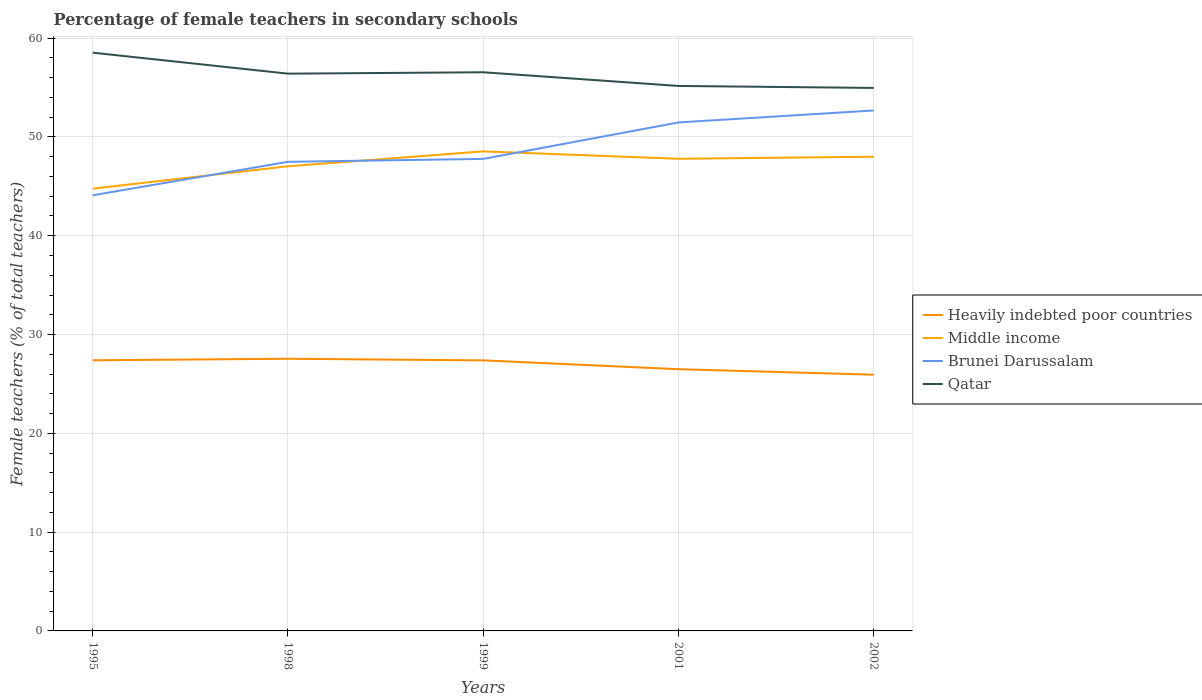How many different coloured lines are there?
Provide a short and direct response. 4. Across all years, what is the maximum percentage of female teachers in Heavily indebted poor countries?
Your answer should be compact. 25.93. In which year was the percentage of female teachers in Heavily indebted poor countries maximum?
Make the answer very short. 2002. What is the total percentage of female teachers in Brunei Darussalam in the graph?
Your answer should be very brief. -4.9. What is the difference between the highest and the second highest percentage of female teachers in Heavily indebted poor countries?
Your answer should be very brief. 1.61. Does the graph contain grids?
Give a very brief answer. Yes. Where does the legend appear in the graph?
Give a very brief answer. Center right. What is the title of the graph?
Your answer should be compact. Percentage of female teachers in secondary schools. Does "Australia" appear as one of the legend labels in the graph?
Offer a very short reply. No. What is the label or title of the Y-axis?
Your answer should be compact. Female teachers (% of total teachers). What is the Female teachers (% of total teachers) of Heavily indebted poor countries in 1995?
Ensure brevity in your answer.  27.39. What is the Female teachers (% of total teachers) in Middle income in 1995?
Provide a succinct answer. 44.76. What is the Female teachers (% of total teachers) in Brunei Darussalam in 1995?
Offer a terse response. 44.09. What is the Female teachers (% of total teachers) in Qatar in 1995?
Offer a very short reply. 58.53. What is the Female teachers (% of total teachers) of Heavily indebted poor countries in 1998?
Keep it short and to the point. 27.55. What is the Female teachers (% of total teachers) of Middle income in 1998?
Your response must be concise. 47.03. What is the Female teachers (% of total teachers) in Brunei Darussalam in 1998?
Keep it short and to the point. 47.48. What is the Female teachers (% of total teachers) of Qatar in 1998?
Provide a succinct answer. 56.4. What is the Female teachers (% of total teachers) in Heavily indebted poor countries in 1999?
Offer a terse response. 27.38. What is the Female teachers (% of total teachers) in Middle income in 1999?
Give a very brief answer. 48.54. What is the Female teachers (% of total teachers) in Brunei Darussalam in 1999?
Provide a short and direct response. 47.78. What is the Female teachers (% of total teachers) in Qatar in 1999?
Your response must be concise. 56.54. What is the Female teachers (% of total teachers) in Heavily indebted poor countries in 2001?
Offer a terse response. 26.49. What is the Female teachers (% of total teachers) of Middle income in 2001?
Make the answer very short. 47.79. What is the Female teachers (% of total teachers) of Brunei Darussalam in 2001?
Give a very brief answer. 51.47. What is the Female teachers (% of total teachers) in Qatar in 2001?
Provide a short and direct response. 55.16. What is the Female teachers (% of total teachers) of Heavily indebted poor countries in 2002?
Your response must be concise. 25.93. What is the Female teachers (% of total teachers) of Middle income in 2002?
Your answer should be very brief. 48. What is the Female teachers (% of total teachers) of Brunei Darussalam in 2002?
Give a very brief answer. 52.68. What is the Female teachers (% of total teachers) in Qatar in 2002?
Keep it short and to the point. 54.96. Across all years, what is the maximum Female teachers (% of total teachers) in Heavily indebted poor countries?
Offer a very short reply. 27.55. Across all years, what is the maximum Female teachers (% of total teachers) of Middle income?
Provide a short and direct response. 48.54. Across all years, what is the maximum Female teachers (% of total teachers) in Brunei Darussalam?
Give a very brief answer. 52.68. Across all years, what is the maximum Female teachers (% of total teachers) of Qatar?
Offer a terse response. 58.53. Across all years, what is the minimum Female teachers (% of total teachers) of Heavily indebted poor countries?
Offer a terse response. 25.93. Across all years, what is the minimum Female teachers (% of total teachers) in Middle income?
Make the answer very short. 44.76. Across all years, what is the minimum Female teachers (% of total teachers) in Brunei Darussalam?
Make the answer very short. 44.09. Across all years, what is the minimum Female teachers (% of total teachers) in Qatar?
Make the answer very short. 54.96. What is the total Female teachers (% of total teachers) in Heavily indebted poor countries in the graph?
Your answer should be very brief. 134.75. What is the total Female teachers (% of total teachers) in Middle income in the graph?
Give a very brief answer. 236.12. What is the total Female teachers (% of total teachers) in Brunei Darussalam in the graph?
Your answer should be very brief. 243.5. What is the total Female teachers (% of total teachers) of Qatar in the graph?
Your answer should be compact. 281.6. What is the difference between the Female teachers (% of total teachers) in Heavily indebted poor countries in 1995 and that in 1998?
Ensure brevity in your answer.  -0.16. What is the difference between the Female teachers (% of total teachers) in Middle income in 1995 and that in 1998?
Ensure brevity in your answer.  -2.26. What is the difference between the Female teachers (% of total teachers) in Brunei Darussalam in 1995 and that in 1998?
Offer a terse response. -3.39. What is the difference between the Female teachers (% of total teachers) in Qatar in 1995 and that in 1998?
Keep it short and to the point. 2.12. What is the difference between the Female teachers (% of total teachers) of Heavily indebted poor countries in 1995 and that in 1999?
Your answer should be compact. 0.01. What is the difference between the Female teachers (% of total teachers) of Middle income in 1995 and that in 1999?
Provide a short and direct response. -3.77. What is the difference between the Female teachers (% of total teachers) of Brunei Darussalam in 1995 and that in 1999?
Your response must be concise. -3.68. What is the difference between the Female teachers (% of total teachers) of Qatar in 1995 and that in 1999?
Your answer should be very brief. 1.98. What is the difference between the Female teachers (% of total teachers) in Heavily indebted poor countries in 1995 and that in 2001?
Your response must be concise. 0.9. What is the difference between the Female teachers (% of total teachers) in Middle income in 1995 and that in 2001?
Offer a terse response. -3.02. What is the difference between the Female teachers (% of total teachers) in Brunei Darussalam in 1995 and that in 2001?
Offer a very short reply. -7.37. What is the difference between the Female teachers (% of total teachers) in Qatar in 1995 and that in 2001?
Provide a succinct answer. 3.37. What is the difference between the Female teachers (% of total teachers) in Heavily indebted poor countries in 1995 and that in 2002?
Keep it short and to the point. 1.46. What is the difference between the Female teachers (% of total teachers) in Middle income in 1995 and that in 2002?
Your answer should be compact. -3.23. What is the difference between the Female teachers (% of total teachers) of Brunei Darussalam in 1995 and that in 2002?
Give a very brief answer. -8.59. What is the difference between the Female teachers (% of total teachers) of Qatar in 1995 and that in 2002?
Provide a short and direct response. 3.57. What is the difference between the Female teachers (% of total teachers) in Heavily indebted poor countries in 1998 and that in 1999?
Provide a succinct answer. 0.17. What is the difference between the Female teachers (% of total teachers) of Middle income in 1998 and that in 1999?
Ensure brevity in your answer.  -1.51. What is the difference between the Female teachers (% of total teachers) in Brunei Darussalam in 1998 and that in 1999?
Give a very brief answer. -0.29. What is the difference between the Female teachers (% of total teachers) in Qatar in 1998 and that in 1999?
Your response must be concise. -0.14. What is the difference between the Female teachers (% of total teachers) of Heavily indebted poor countries in 1998 and that in 2001?
Keep it short and to the point. 1.06. What is the difference between the Female teachers (% of total teachers) of Middle income in 1998 and that in 2001?
Keep it short and to the point. -0.76. What is the difference between the Female teachers (% of total teachers) in Brunei Darussalam in 1998 and that in 2001?
Provide a succinct answer. -3.98. What is the difference between the Female teachers (% of total teachers) in Qatar in 1998 and that in 2001?
Provide a succinct answer. 1.25. What is the difference between the Female teachers (% of total teachers) of Heavily indebted poor countries in 1998 and that in 2002?
Offer a very short reply. 1.61. What is the difference between the Female teachers (% of total teachers) of Middle income in 1998 and that in 2002?
Your response must be concise. -0.97. What is the difference between the Female teachers (% of total teachers) of Brunei Darussalam in 1998 and that in 2002?
Your answer should be very brief. -5.2. What is the difference between the Female teachers (% of total teachers) of Qatar in 1998 and that in 2002?
Your answer should be very brief. 1.44. What is the difference between the Female teachers (% of total teachers) of Heavily indebted poor countries in 1999 and that in 2001?
Ensure brevity in your answer.  0.89. What is the difference between the Female teachers (% of total teachers) in Middle income in 1999 and that in 2001?
Provide a succinct answer. 0.75. What is the difference between the Female teachers (% of total teachers) of Brunei Darussalam in 1999 and that in 2001?
Your answer should be compact. -3.69. What is the difference between the Female teachers (% of total teachers) in Qatar in 1999 and that in 2001?
Give a very brief answer. 1.39. What is the difference between the Female teachers (% of total teachers) of Heavily indebted poor countries in 1999 and that in 2002?
Provide a succinct answer. 1.45. What is the difference between the Female teachers (% of total teachers) in Middle income in 1999 and that in 2002?
Provide a succinct answer. 0.54. What is the difference between the Female teachers (% of total teachers) in Brunei Darussalam in 1999 and that in 2002?
Your answer should be very brief. -4.9. What is the difference between the Female teachers (% of total teachers) in Qatar in 1999 and that in 2002?
Give a very brief answer. 1.58. What is the difference between the Female teachers (% of total teachers) of Heavily indebted poor countries in 2001 and that in 2002?
Ensure brevity in your answer.  0.56. What is the difference between the Female teachers (% of total teachers) of Middle income in 2001 and that in 2002?
Your answer should be very brief. -0.21. What is the difference between the Female teachers (% of total teachers) in Brunei Darussalam in 2001 and that in 2002?
Your answer should be very brief. -1.21. What is the difference between the Female teachers (% of total teachers) of Qatar in 2001 and that in 2002?
Your answer should be compact. 0.2. What is the difference between the Female teachers (% of total teachers) of Heavily indebted poor countries in 1995 and the Female teachers (% of total teachers) of Middle income in 1998?
Keep it short and to the point. -19.64. What is the difference between the Female teachers (% of total teachers) of Heavily indebted poor countries in 1995 and the Female teachers (% of total teachers) of Brunei Darussalam in 1998?
Keep it short and to the point. -20.09. What is the difference between the Female teachers (% of total teachers) of Heavily indebted poor countries in 1995 and the Female teachers (% of total teachers) of Qatar in 1998?
Provide a succinct answer. -29.01. What is the difference between the Female teachers (% of total teachers) of Middle income in 1995 and the Female teachers (% of total teachers) of Brunei Darussalam in 1998?
Provide a short and direct response. -2.72. What is the difference between the Female teachers (% of total teachers) of Middle income in 1995 and the Female teachers (% of total teachers) of Qatar in 1998?
Offer a terse response. -11.64. What is the difference between the Female teachers (% of total teachers) of Brunei Darussalam in 1995 and the Female teachers (% of total teachers) of Qatar in 1998?
Offer a terse response. -12.31. What is the difference between the Female teachers (% of total teachers) of Heavily indebted poor countries in 1995 and the Female teachers (% of total teachers) of Middle income in 1999?
Provide a short and direct response. -21.14. What is the difference between the Female teachers (% of total teachers) of Heavily indebted poor countries in 1995 and the Female teachers (% of total teachers) of Brunei Darussalam in 1999?
Provide a succinct answer. -20.38. What is the difference between the Female teachers (% of total teachers) in Heavily indebted poor countries in 1995 and the Female teachers (% of total teachers) in Qatar in 1999?
Keep it short and to the point. -29.15. What is the difference between the Female teachers (% of total teachers) in Middle income in 1995 and the Female teachers (% of total teachers) in Brunei Darussalam in 1999?
Provide a short and direct response. -3.01. What is the difference between the Female teachers (% of total teachers) in Middle income in 1995 and the Female teachers (% of total teachers) in Qatar in 1999?
Offer a terse response. -11.78. What is the difference between the Female teachers (% of total teachers) in Brunei Darussalam in 1995 and the Female teachers (% of total teachers) in Qatar in 1999?
Keep it short and to the point. -12.45. What is the difference between the Female teachers (% of total teachers) in Heavily indebted poor countries in 1995 and the Female teachers (% of total teachers) in Middle income in 2001?
Your answer should be compact. -20.4. What is the difference between the Female teachers (% of total teachers) of Heavily indebted poor countries in 1995 and the Female teachers (% of total teachers) of Brunei Darussalam in 2001?
Your response must be concise. -24.07. What is the difference between the Female teachers (% of total teachers) of Heavily indebted poor countries in 1995 and the Female teachers (% of total teachers) of Qatar in 2001?
Keep it short and to the point. -27.77. What is the difference between the Female teachers (% of total teachers) of Middle income in 1995 and the Female teachers (% of total teachers) of Brunei Darussalam in 2001?
Ensure brevity in your answer.  -6.7. What is the difference between the Female teachers (% of total teachers) of Middle income in 1995 and the Female teachers (% of total teachers) of Qatar in 2001?
Ensure brevity in your answer.  -10.39. What is the difference between the Female teachers (% of total teachers) in Brunei Darussalam in 1995 and the Female teachers (% of total teachers) in Qatar in 2001?
Make the answer very short. -11.07. What is the difference between the Female teachers (% of total teachers) of Heavily indebted poor countries in 1995 and the Female teachers (% of total teachers) of Middle income in 2002?
Your answer should be very brief. -20.6. What is the difference between the Female teachers (% of total teachers) of Heavily indebted poor countries in 1995 and the Female teachers (% of total teachers) of Brunei Darussalam in 2002?
Your response must be concise. -25.29. What is the difference between the Female teachers (% of total teachers) of Heavily indebted poor countries in 1995 and the Female teachers (% of total teachers) of Qatar in 2002?
Give a very brief answer. -27.57. What is the difference between the Female teachers (% of total teachers) in Middle income in 1995 and the Female teachers (% of total teachers) in Brunei Darussalam in 2002?
Offer a very short reply. -7.91. What is the difference between the Female teachers (% of total teachers) in Middle income in 1995 and the Female teachers (% of total teachers) in Qatar in 2002?
Keep it short and to the point. -10.2. What is the difference between the Female teachers (% of total teachers) in Brunei Darussalam in 1995 and the Female teachers (% of total teachers) in Qatar in 2002?
Offer a very short reply. -10.87. What is the difference between the Female teachers (% of total teachers) in Heavily indebted poor countries in 1998 and the Female teachers (% of total teachers) in Middle income in 1999?
Your answer should be compact. -20.99. What is the difference between the Female teachers (% of total teachers) of Heavily indebted poor countries in 1998 and the Female teachers (% of total teachers) of Brunei Darussalam in 1999?
Your answer should be very brief. -20.23. What is the difference between the Female teachers (% of total teachers) in Heavily indebted poor countries in 1998 and the Female teachers (% of total teachers) in Qatar in 1999?
Make the answer very short. -29. What is the difference between the Female teachers (% of total teachers) of Middle income in 1998 and the Female teachers (% of total teachers) of Brunei Darussalam in 1999?
Your answer should be very brief. -0.75. What is the difference between the Female teachers (% of total teachers) in Middle income in 1998 and the Female teachers (% of total teachers) in Qatar in 1999?
Make the answer very short. -9.51. What is the difference between the Female teachers (% of total teachers) in Brunei Darussalam in 1998 and the Female teachers (% of total teachers) in Qatar in 1999?
Your answer should be compact. -9.06. What is the difference between the Female teachers (% of total teachers) of Heavily indebted poor countries in 1998 and the Female teachers (% of total teachers) of Middle income in 2001?
Provide a succinct answer. -20.24. What is the difference between the Female teachers (% of total teachers) of Heavily indebted poor countries in 1998 and the Female teachers (% of total teachers) of Brunei Darussalam in 2001?
Offer a terse response. -23.92. What is the difference between the Female teachers (% of total teachers) of Heavily indebted poor countries in 1998 and the Female teachers (% of total teachers) of Qatar in 2001?
Your response must be concise. -27.61. What is the difference between the Female teachers (% of total teachers) in Middle income in 1998 and the Female teachers (% of total teachers) in Brunei Darussalam in 2001?
Your response must be concise. -4.44. What is the difference between the Female teachers (% of total teachers) in Middle income in 1998 and the Female teachers (% of total teachers) in Qatar in 2001?
Make the answer very short. -8.13. What is the difference between the Female teachers (% of total teachers) of Brunei Darussalam in 1998 and the Female teachers (% of total teachers) of Qatar in 2001?
Give a very brief answer. -7.68. What is the difference between the Female teachers (% of total teachers) in Heavily indebted poor countries in 1998 and the Female teachers (% of total teachers) in Middle income in 2002?
Offer a very short reply. -20.45. What is the difference between the Female teachers (% of total teachers) in Heavily indebted poor countries in 1998 and the Female teachers (% of total teachers) in Brunei Darussalam in 2002?
Your answer should be very brief. -25.13. What is the difference between the Female teachers (% of total teachers) of Heavily indebted poor countries in 1998 and the Female teachers (% of total teachers) of Qatar in 2002?
Your answer should be very brief. -27.41. What is the difference between the Female teachers (% of total teachers) of Middle income in 1998 and the Female teachers (% of total teachers) of Brunei Darussalam in 2002?
Ensure brevity in your answer.  -5.65. What is the difference between the Female teachers (% of total teachers) of Middle income in 1998 and the Female teachers (% of total teachers) of Qatar in 2002?
Provide a succinct answer. -7.93. What is the difference between the Female teachers (% of total teachers) in Brunei Darussalam in 1998 and the Female teachers (% of total teachers) in Qatar in 2002?
Provide a succinct answer. -7.48. What is the difference between the Female teachers (% of total teachers) in Heavily indebted poor countries in 1999 and the Female teachers (% of total teachers) in Middle income in 2001?
Your answer should be very brief. -20.41. What is the difference between the Female teachers (% of total teachers) of Heavily indebted poor countries in 1999 and the Female teachers (% of total teachers) of Brunei Darussalam in 2001?
Your response must be concise. -24.08. What is the difference between the Female teachers (% of total teachers) in Heavily indebted poor countries in 1999 and the Female teachers (% of total teachers) in Qatar in 2001?
Your response must be concise. -27.78. What is the difference between the Female teachers (% of total teachers) in Middle income in 1999 and the Female teachers (% of total teachers) in Brunei Darussalam in 2001?
Ensure brevity in your answer.  -2.93. What is the difference between the Female teachers (% of total teachers) of Middle income in 1999 and the Female teachers (% of total teachers) of Qatar in 2001?
Offer a very short reply. -6.62. What is the difference between the Female teachers (% of total teachers) in Brunei Darussalam in 1999 and the Female teachers (% of total teachers) in Qatar in 2001?
Offer a very short reply. -7.38. What is the difference between the Female teachers (% of total teachers) in Heavily indebted poor countries in 1999 and the Female teachers (% of total teachers) in Middle income in 2002?
Your answer should be compact. -20.61. What is the difference between the Female teachers (% of total teachers) of Heavily indebted poor countries in 1999 and the Female teachers (% of total teachers) of Brunei Darussalam in 2002?
Offer a terse response. -25.3. What is the difference between the Female teachers (% of total teachers) in Heavily indebted poor countries in 1999 and the Female teachers (% of total teachers) in Qatar in 2002?
Keep it short and to the point. -27.58. What is the difference between the Female teachers (% of total teachers) in Middle income in 1999 and the Female teachers (% of total teachers) in Brunei Darussalam in 2002?
Keep it short and to the point. -4.14. What is the difference between the Female teachers (% of total teachers) in Middle income in 1999 and the Female teachers (% of total teachers) in Qatar in 2002?
Offer a terse response. -6.42. What is the difference between the Female teachers (% of total teachers) in Brunei Darussalam in 1999 and the Female teachers (% of total teachers) in Qatar in 2002?
Your response must be concise. -7.18. What is the difference between the Female teachers (% of total teachers) of Heavily indebted poor countries in 2001 and the Female teachers (% of total teachers) of Middle income in 2002?
Offer a very short reply. -21.51. What is the difference between the Female teachers (% of total teachers) in Heavily indebted poor countries in 2001 and the Female teachers (% of total teachers) in Brunei Darussalam in 2002?
Make the answer very short. -26.19. What is the difference between the Female teachers (% of total teachers) in Heavily indebted poor countries in 2001 and the Female teachers (% of total teachers) in Qatar in 2002?
Your answer should be very brief. -28.47. What is the difference between the Female teachers (% of total teachers) of Middle income in 2001 and the Female teachers (% of total teachers) of Brunei Darussalam in 2002?
Provide a short and direct response. -4.89. What is the difference between the Female teachers (% of total teachers) in Middle income in 2001 and the Female teachers (% of total teachers) in Qatar in 2002?
Provide a short and direct response. -7.17. What is the difference between the Female teachers (% of total teachers) of Brunei Darussalam in 2001 and the Female teachers (% of total teachers) of Qatar in 2002?
Keep it short and to the point. -3.49. What is the average Female teachers (% of total teachers) of Heavily indebted poor countries per year?
Offer a terse response. 26.95. What is the average Female teachers (% of total teachers) of Middle income per year?
Make the answer very short. 47.22. What is the average Female teachers (% of total teachers) in Brunei Darussalam per year?
Offer a terse response. 48.7. What is the average Female teachers (% of total teachers) in Qatar per year?
Ensure brevity in your answer.  56.32. In the year 1995, what is the difference between the Female teachers (% of total teachers) of Heavily indebted poor countries and Female teachers (% of total teachers) of Middle income?
Your answer should be very brief. -17.37. In the year 1995, what is the difference between the Female teachers (% of total teachers) of Heavily indebted poor countries and Female teachers (% of total teachers) of Brunei Darussalam?
Provide a succinct answer. -16.7. In the year 1995, what is the difference between the Female teachers (% of total teachers) in Heavily indebted poor countries and Female teachers (% of total teachers) in Qatar?
Offer a terse response. -31.13. In the year 1995, what is the difference between the Female teachers (% of total teachers) in Middle income and Female teachers (% of total teachers) in Brunei Darussalam?
Your response must be concise. 0.67. In the year 1995, what is the difference between the Female teachers (% of total teachers) of Middle income and Female teachers (% of total teachers) of Qatar?
Provide a short and direct response. -13.76. In the year 1995, what is the difference between the Female teachers (% of total teachers) in Brunei Darussalam and Female teachers (% of total teachers) in Qatar?
Offer a very short reply. -14.43. In the year 1998, what is the difference between the Female teachers (% of total teachers) of Heavily indebted poor countries and Female teachers (% of total teachers) of Middle income?
Offer a terse response. -19.48. In the year 1998, what is the difference between the Female teachers (% of total teachers) in Heavily indebted poor countries and Female teachers (% of total teachers) in Brunei Darussalam?
Your answer should be compact. -19.93. In the year 1998, what is the difference between the Female teachers (% of total teachers) of Heavily indebted poor countries and Female teachers (% of total teachers) of Qatar?
Your answer should be compact. -28.86. In the year 1998, what is the difference between the Female teachers (% of total teachers) in Middle income and Female teachers (% of total teachers) in Brunei Darussalam?
Ensure brevity in your answer.  -0.45. In the year 1998, what is the difference between the Female teachers (% of total teachers) in Middle income and Female teachers (% of total teachers) in Qatar?
Provide a succinct answer. -9.38. In the year 1998, what is the difference between the Female teachers (% of total teachers) of Brunei Darussalam and Female teachers (% of total teachers) of Qatar?
Provide a short and direct response. -8.92. In the year 1999, what is the difference between the Female teachers (% of total teachers) of Heavily indebted poor countries and Female teachers (% of total teachers) of Middle income?
Your answer should be very brief. -21.15. In the year 1999, what is the difference between the Female teachers (% of total teachers) of Heavily indebted poor countries and Female teachers (% of total teachers) of Brunei Darussalam?
Your answer should be very brief. -20.39. In the year 1999, what is the difference between the Female teachers (% of total teachers) in Heavily indebted poor countries and Female teachers (% of total teachers) in Qatar?
Keep it short and to the point. -29.16. In the year 1999, what is the difference between the Female teachers (% of total teachers) in Middle income and Female teachers (% of total teachers) in Brunei Darussalam?
Your response must be concise. 0.76. In the year 1999, what is the difference between the Female teachers (% of total teachers) of Middle income and Female teachers (% of total teachers) of Qatar?
Offer a terse response. -8.01. In the year 1999, what is the difference between the Female teachers (% of total teachers) in Brunei Darussalam and Female teachers (% of total teachers) in Qatar?
Offer a terse response. -8.77. In the year 2001, what is the difference between the Female teachers (% of total teachers) in Heavily indebted poor countries and Female teachers (% of total teachers) in Middle income?
Make the answer very short. -21.3. In the year 2001, what is the difference between the Female teachers (% of total teachers) in Heavily indebted poor countries and Female teachers (% of total teachers) in Brunei Darussalam?
Your answer should be compact. -24.98. In the year 2001, what is the difference between the Female teachers (% of total teachers) in Heavily indebted poor countries and Female teachers (% of total teachers) in Qatar?
Ensure brevity in your answer.  -28.67. In the year 2001, what is the difference between the Female teachers (% of total teachers) of Middle income and Female teachers (% of total teachers) of Brunei Darussalam?
Your answer should be very brief. -3.68. In the year 2001, what is the difference between the Female teachers (% of total teachers) in Middle income and Female teachers (% of total teachers) in Qatar?
Your answer should be very brief. -7.37. In the year 2001, what is the difference between the Female teachers (% of total teachers) of Brunei Darussalam and Female teachers (% of total teachers) of Qatar?
Your response must be concise. -3.69. In the year 2002, what is the difference between the Female teachers (% of total teachers) in Heavily indebted poor countries and Female teachers (% of total teachers) in Middle income?
Your answer should be compact. -22.06. In the year 2002, what is the difference between the Female teachers (% of total teachers) in Heavily indebted poor countries and Female teachers (% of total teachers) in Brunei Darussalam?
Your answer should be compact. -26.74. In the year 2002, what is the difference between the Female teachers (% of total teachers) in Heavily indebted poor countries and Female teachers (% of total teachers) in Qatar?
Provide a succinct answer. -29.03. In the year 2002, what is the difference between the Female teachers (% of total teachers) in Middle income and Female teachers (% of total teachers) in Brunei Darussalam?
Give a very brief answer. -4.68. In the year 2002, what is the difference between the Female teachers (% of total teachers) of Middle income and Female teachers (% of total teachers) of Qatar?
Your answer should be very brief. -6.96. In the year 2002, what is the difference between the Female teachers (% of total teachers) in Brunei Darussalam and Female teachers (% of total teachers) in Qatar?
Your answer should be very brief. -2.28. What is the ratio of the Female teachers (% of total teachers) in Heavily indebted poor countries in 1995 to that in 1998?
Provide a short and direct response. 0.99. What is the ratio of the Female teachers (% of total teachers) in Middle income in 1995 to that in 1998?
Offer a very short reply. 0.95. What is the ratio of the Female teachers (% of total teachers) of Brunei Darussalam in 1995 to that in 1998?
Provide a short and direct response. 0.93. What is the ratio of the Female teachers (% of total teachers) in Qatar in 1995 to that in 1998?
Provide a succinct answer. 1.04. What is the ratio of the Female teachers (% of total teachers) of Heavily indebted poor countries in 1995 to that in 1999?
Give a very brief answer. 1. What is the ratio of the Female teachers (% of total teachers) in Middle income in 1995 to that in 1999?
Ensure brevity in your answer.  0.92. What is the ratio of the Female teachers (% of total teachers) in Brunei Darussalam in 1995 to that in 1999?
Give a very brief answer. 0.92. What is the ratio of the Female teachers (% of total teachers) of Qatar in 1995 to that in 1999?
Provide a succinct answer. 1.04. What is the ratio of the Female teachers (% of total teachers) in Heavily indebted poor countries in 1995 to that in 2001?
Ensure brevity in your answer.  1.03. What is the ratio of the Female teachers (% of total teachers) in Middle income in 1995 to that in 2001?
Your response must be concise. 0.94. What is the ratio of the Female teachers (% of total teachers) in Brunei Darussalam in 1995 to that in 2001?
Your response must be concise. 0.86. What is the ratio of the Female teachers (% of total teachers) of Qatar in 1995 to that in 2001?
Your answer should be compact. 1.06. What is the ratio of the Female teachers (% of total teachers) in Heavily indebted poor countries in 1995 to that in 2002?
Provide a succinct answer. 1.06. What is the ratio of the Female teachers (% of total teachers) of Middle income in 1995 to that in 2002?
Offer a very short reply. 0.93. What is the ratio of the Female teachers (% of total teachers) of Brunei Darussalam in 1995 to that in 2002?
Make the answer very short. 0.84. What is the ratio of the Female teachers (% of total teachers) in Qatar in 1995 to that in 2002?
Provide a succinct answer. 1.06. What is the ratio of the Female teachers (% of total teachers) in Heavily indebted poor countries in 1998 to that in 1999?
Make the answer very short. 1.01. What is the ratio of the Female teachers (% of total teachers) of Middle income in 1998 to that in 1999?
Provide a short and direct response. 0.97. What is the ratio of the Female teachers (% of total teachers) in Qatar in 1998 to that in 1999?
Provide a short and direct response. 1. What is the ratio of the Female teachers (% of total teachers) of Middle income in 1998 to that in 2001?
Provide a short and direct response. 0.98. What is the ratio of the Female teachers (% of total teachers) of Brunei Darussalam in 1998 to that in 2001?
Give a very brief answer. 0.92. What is the ratio of the Female teachers (% of total teachers) of Qatar in 1998 to that in 2001?
Offer a very short reply. 1.02. What is the ratio of the Female teachers (% of total teachers) in Heavily indebted poor countries in 1998 to that in 2002?
Keep it short and to the point. 1.06. What is the ratio of the Female teachers (% of total teachers) of Middle income in 1998 to that in 2002?
Make the answer very short. 0.98. What is the ratio of the Female teachers (% of total teachers) of Brunei Darussalam in 1998 to that in 2002?
Your answer should be very brief. 0.9. What is the ratio of the Female teachers (% of total teachers) in Qatar in 1998 to that in 2002?
Provide a short and direct response. 1.03. What is the ratio of the Female teachers (% of total teachers) in Heavily indebted poor countries in 1999 to that in 2001?
Your response must be concise. 1.03. What is the ratio of the Female teachers (% of total teachers) of Middle income in 1999 to that in 2001?
Your answer should be very brief. 1.02. What is the ratio of the Female teachers (% of total teachers) of Brunei Darussalam in 1999 to that in 2001?
Offer a terse response. 0.93. What is the ratio of the Female teachers (% of total teachers) in Qatar in 1999 to that in 2001?
Your answer should be compact. 1.03. What is the ratio of the Female teachers (% of total teachers) in Heavily indebted poor countries in 1999 to that in 2002?
Offer a terse response. 1.06. What is the ratio of the Female teachers (% of total teachers) in Middle income in 1999 to that in 2002?
Provide a succinct answer. 1.01. What is the ratio of the Female teachers (% of total teachers) of Brunei Darussalam in 1999 to that in 2002?
Ensure brevity in your answer.  0.91. What is the ratio of the Female teachers (% of total teachers) of Qatar in 1999 to that in 2002?
Ensure brevity in your answer.  1.03. What is the ratio of the Female teachers (% of total teachers) of Heavily indebted poor countries in 2001 to that in 2002?
Your answer should be compact. 1.02. What is the ratio of the Female teachers (% of total teachers) of Brunei Darussalam in 2001 to that in 2002?
Offer a very short reply. 0.98. What is the difference between the highest and the second highest Female teachers (% of total teachers) in Heavily indebted poor countries?
Provide a succinct answer. 0.16. What is the difference between the highest and the second highest Female teachers (% of total teachers) in Middle income?
Give a very brief answer. 0.54. What is the difference between the highest and the second highest Female teachers (% of total teachers) of Brunei Darussalam?
Offer a terse response. 1.21. What is the difference between the highest and the second highest Female teachers (% of total teachers) in Qatar?
Your answer should be compact. 1.98. What is the difference between the highest and the lowest Female teachers (% of total teachers) of Heavily indebted poor countries?
Provide a short and direct response. 1.61. What is the difference between the highest and the lowest Female teachers (% of total teachers) of Middle income?
Keep it short and to the point. 3.77. What is the difference between the highest and the lowest Female teachers (% of total teachers) of Brunei Darussalam?
Offer a terse response. 8.59. What is the difference between the highest and the lowest Female teachers (% of total teachers) of Qatar?
Provide a succinct answer. 3.57. 